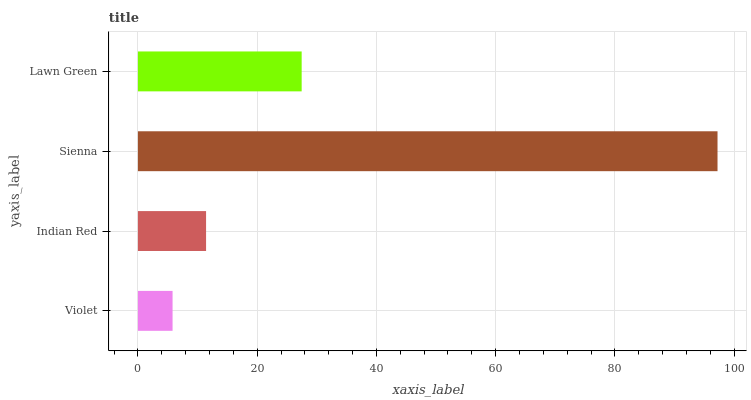Is Violet the minimum?
Answer yes or no. Yes. Is Sienna the maximum?
Answer yes or no. Yes. Is Indian Red the minimum?
Answer yes or no. No. Is Indian Red the maximum?
Answer yes or no. No. Is Indian Red greater than Violet?
Answer yes or no. Yes. Is Violet less than Indian Red?
Answer yes or no. Yes. Is Violet greater than Indian Red?
Answer yes or no. No. Is Indian Red less than Violet?
Answer yes or no. No. Is Lawn Green the high median?
Answer yes or no. Yes. Is Indian Red the low median?
Answer yes or no. Yes. Is Violet the high median?
Answer yes or no. No. Is Lawn Green the low median?
Answer yes or no. No. 